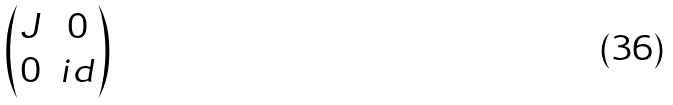<formula> <loc_0><loc_0><loc_500><loc_500>\begin{pmatrix} J & 0 \\ 0 & i d \end{pmatrix}</formula> 